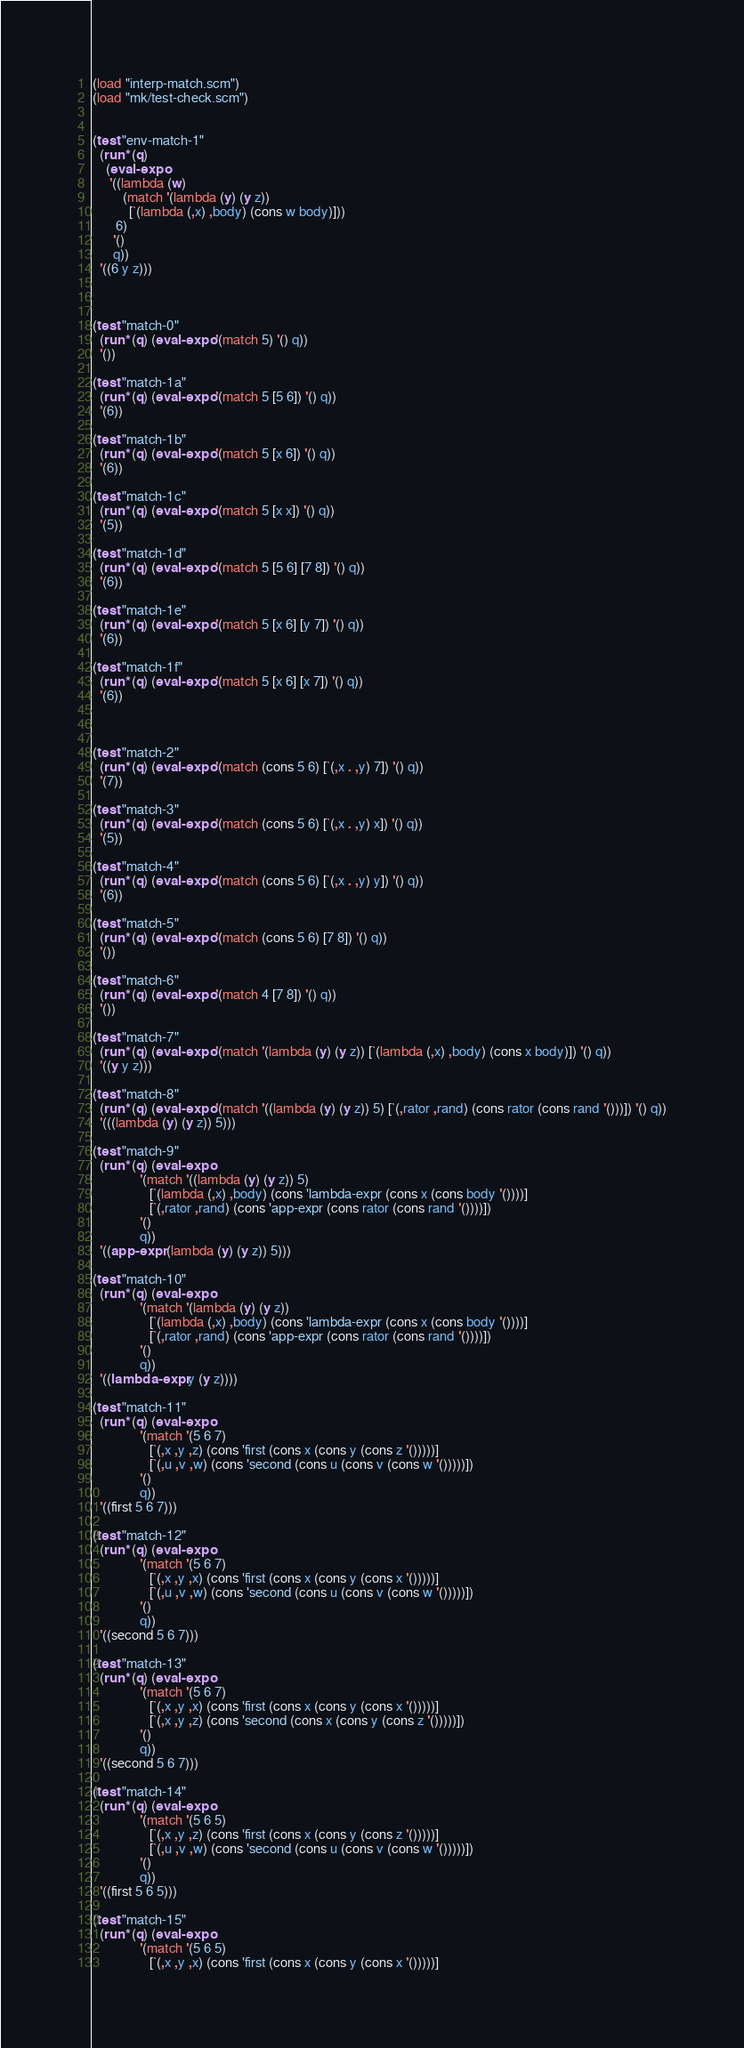<code> <loc_0><loc_0><loc_500><loc_500><_Scheme_>(load "interp-match.scm")
(load "mk/test-check.scm")


(test "env-match-1"
  (run* (q)
    (eval-expo
     '((lambda (w)
         (match '(lambda (y) (y z))
           [`(lambda (,x) ,body) (cons w body)]))
       6)
      '()
      q))
  '((6 y z)))



(test "match-0"
  (run* (q) (eval-expo '(match 5) '() q))
  '())

(test "match-1a"
  (run* (q) (eval-expo '(match 5 [5 6]) '() q))
  '(6))

(test "match-1b"
  (run* (q) (eval-expo '(match 5 [x 6]) '() q))
  '(6))

(test "match-1c"
  (run* (q) (eval-expo '(match 5 [x x]) '() q))
  '(5))

(test "match-1d"
  (run* (q) (eval-expo '(match 5 [5 6] [7 8]) '() q))
  '(6))

(test "match-1e"
  (run* (q) (eval-expo '(match 5 [x 6] [y 7]) '() q))
  '(6))

(test "match-1f"
  (run* (q) (eval-expo '(match 5 [x 6] [x 7]) '() q))
  '(6))



(test "match-2"
  (run* (q) (eval-expo '(match (cons 5 6) [`(,x . ,y) 7]) '() q))
  '(7))

(test "match-3"
  (run* (q) (eval-expo '(match (cons 5 6) [`(,x . ,y) x]) '() q))
  '(5))

(test "match-4"
  (run* (q) (eval-expo '(match (cons 5 6) [`(,x . ,y) y]) '() q))
  '(6))

(test "match-5"
  (run* (q) (eval-expo '(match (cons 5 6) [7 8]) '() q))
  '())

(test "match-6"
  (run* (q) (eval-expo '(match 4 [7 8]) '() q))
  '())

(test "match-7"
  (run* (q) (eval-expo '(match '(lambda (y) (y z)) [`(lambda (,x) ,body) (cons x body)]) '() q))
  '((y y z)))

(test "match-8"
  (run* (q) (eval-expo '(match '((lambda (y) (y z)) 5) [`(,rator ,rand) (cons rator (cons rand '()))]) '() q))
  '(((lambda (y) (y z)) 5)))

(test "match-9"
  (run* (q) (eval-expo
              '(match '((lambda (y) (y z)) 5)
                 [`(lambda (,x) ,body) (cons 'lambda-expr (cons x (cons body '())))]
                 [`(,rator ,rand) (cons 'app-expr (cons rator (cons rand '())))])
              '()
              q))
  '((app-expr (lambda (y) (y z)) 5)))

(test "match-10"
  (run* (q) (eval-expo
              '(match '(lambda (y) (y z))
                 [`(lambda (,x) ,body) (cons 'lambda-expr (cons x (cons body '())))]
                 [`(,rator ,rand) (cons 'app-expr (cons rator (cons rand '())))])
              '()
              q))
  '((lambda-expr y (y z))))

(test "match-11"
  (run* (q) (eval-expo
              '(match '(5 6 7)
                 [`(,x ,y ,z) (cons 'first (cons x (cons y (cons z '()))))]
                 [`(,u ,v ,w) (cons 'second (cons u (cons v (cons w '()))))])
              '()
              q))
  '((first 5 6 7)))

(test "match-12"
  (run* (q) (eval-expo
              '(match '(5 6 7)
                 [`(,x ,y ,x) (cons 'first (cons x (cons y (cons x '()))))]
                 [`(,u ,v ,w) (cons 'second (cons u (cons v (cons w '()))))])
              '()
              q))
  '((second 5 6 7)))

(test "match-13"
  (run* (q) (eval-expo
              '(match '(5 6 7)
                 [`(,x ,y ,x) (cons 'first (cons x (cons y (cons x '()))))]
                 [`(,x ,y ,z) (cons 'second (cons x (cons y (cons z '()))))])
              '()
              q))
  '((second 5 6 7)))

(test "match-14"
  (run* (q) (eval-expo
              '(match '(5 6 5)
                 [`(,x ,y ,z) (cons 'first (cons x (cons y (cons z '()))))]
                 [`(,u ,v ,w) (cons 'second (cons u (cons v (cons w '()))))])
              '()
              q))
  '((first 5 6 5)))

(test "match-15"
  (run* (q) (eval-expo
              '(match '(5 6 5)
                 [`(,x ,y ,x) (cons 'first (cons x (cons y (cons x '()))))]</code> 